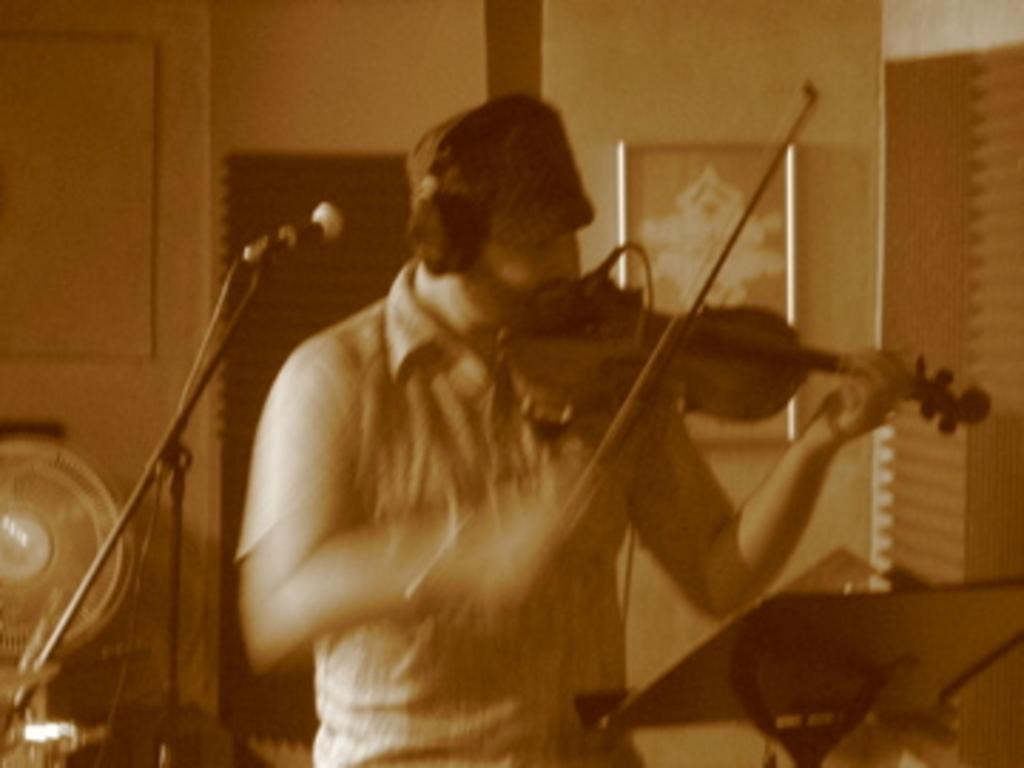Can you describe this image briefly? There is a person holding a violin and playing. He is wearing a cap and headset. In front of him there is a mic and mic stand. In the background there is a wall, photo frame, and a fan. In the front there is a book stand. 